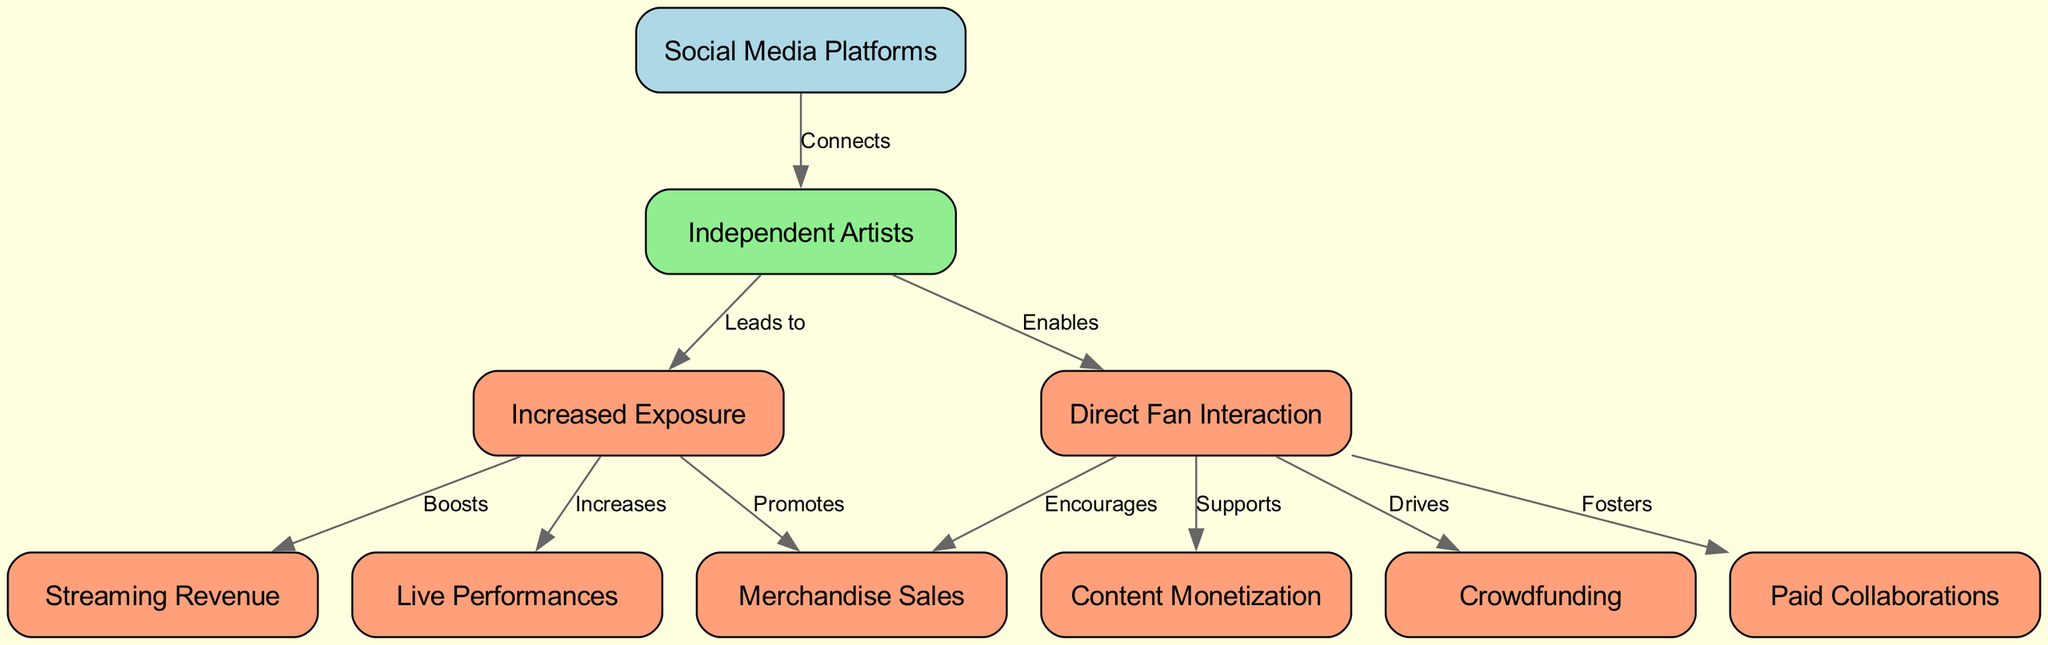What is the total number of nodes in the diagram? There are 10 nodes in the diagram, which are listed under the “nodes” section of the data provided.
Answer: 10 Which node represents "Increased Exposure"? The node labeled "Increased Exposure" is identified by the ID "a3" in the diagram.
Answer: Increased Exposure How many edges connect "Independent Artists" to other nodes? The node "Independent Artists" (a2) connects to 4 different nodes through edges, indicating the different influences of social media on artists.
Answer: 4 What does "Direct Fan Interaction" drive? "Direct Fan Interaction" (a4) drives "Crowdfunding" (a5), which means it has an influence on funding for independent artists.
Answer: Crowdfunding From "Increased Exposure", what is promoted? "Increased Exposure" (a3) promotes "Merchandise Sales" (a6), which suggests a direct beneficial effect on artists' sales from greater visibility.
Answer: Merchandise Sales What relationship exists between "Direct Fan Interaction" and "Content Monetization"? "Direct Fan Interaction" (a4) supports "Content Monetization" (a10), showing that engagement with fans can lead to revenue generation from content.
Answer: Supports How many types of income sources are linked from "Increased Exposure"? "Increased Exposure" (a3) links directly to two income sources: "Streaming Revenue" (a7) and "Live Performances" (a8). This indicates it enhances these specific earnings for artists.
Answer: 2 Which node is connected to "Social Media Platforms" by the relationship labeled "Connects"? The node connected to "Social Media Platforms" (a1) with the relationship labeled "Connects" is "Independent Artists" (a2), reflecting how platforms facilitate connections between them.
Answer: Independent Artists What does "Increased Exposure" boost? "Increased Exposure" (a3) boosts "Streaming Revenue" (a7) and "Live Performances" (a8), indicating a positive impact of visibility on these specific earnings.
Answer: Streaming Revenue, Live Performances 